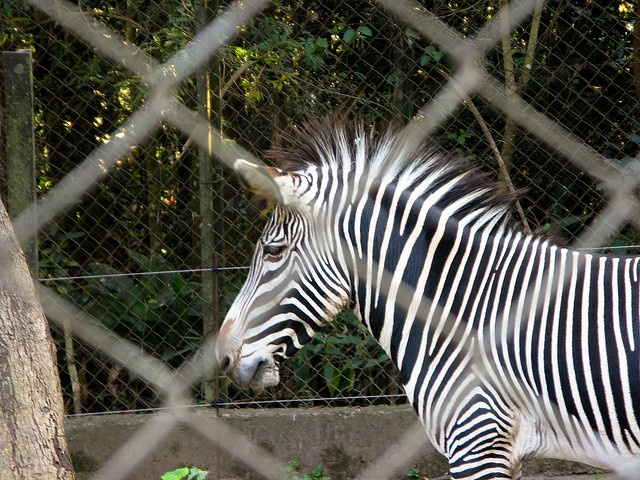Describe the objects in this image and their specific colors. I can see a zebra in black, white, gray, and darkgray tones in this image. 